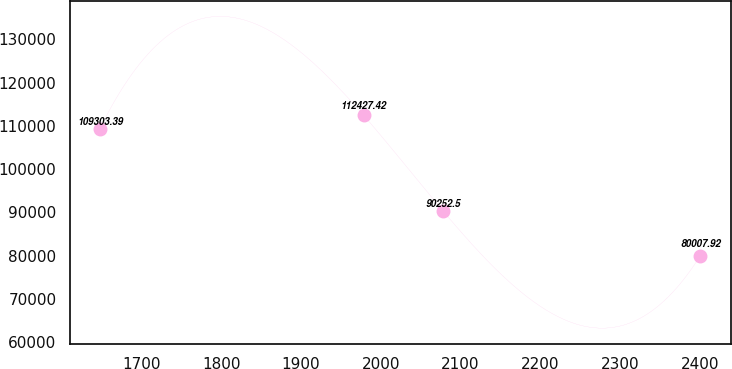Convert chart to OTSL. <chart><loc_0><loc_0><loc_500><loc_500><line_chart><ecel><fcel>Unnamed: 1<nl><fcel>1647.93<fcel>109303<nl><fcel>1978.79<fcel>112427<nl><fcel>2078.47<fcel>90252.5<nl><fcel>2400.83<fcel>80007.9<nl></chart> 